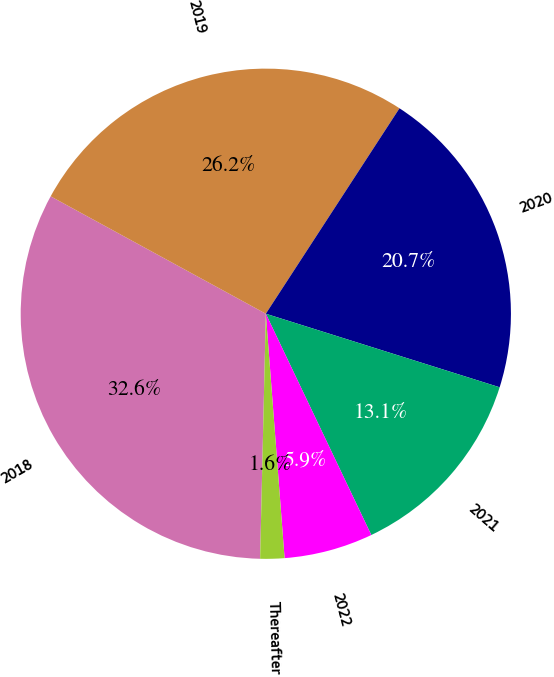Convert chart. <chart><loc_0><loc_0><loc_500><loc_500><pie_chart><fcel>2018<fcel>2019<fcel>2020<fcel>2021<fcel>2022<fcel>Thereafter<nl><fcel>32.58%<fcel>26.23%<fcel>20.67%<fcel>13.07%<fcel>5.86%<fcel>1.59%<nl></chart> 